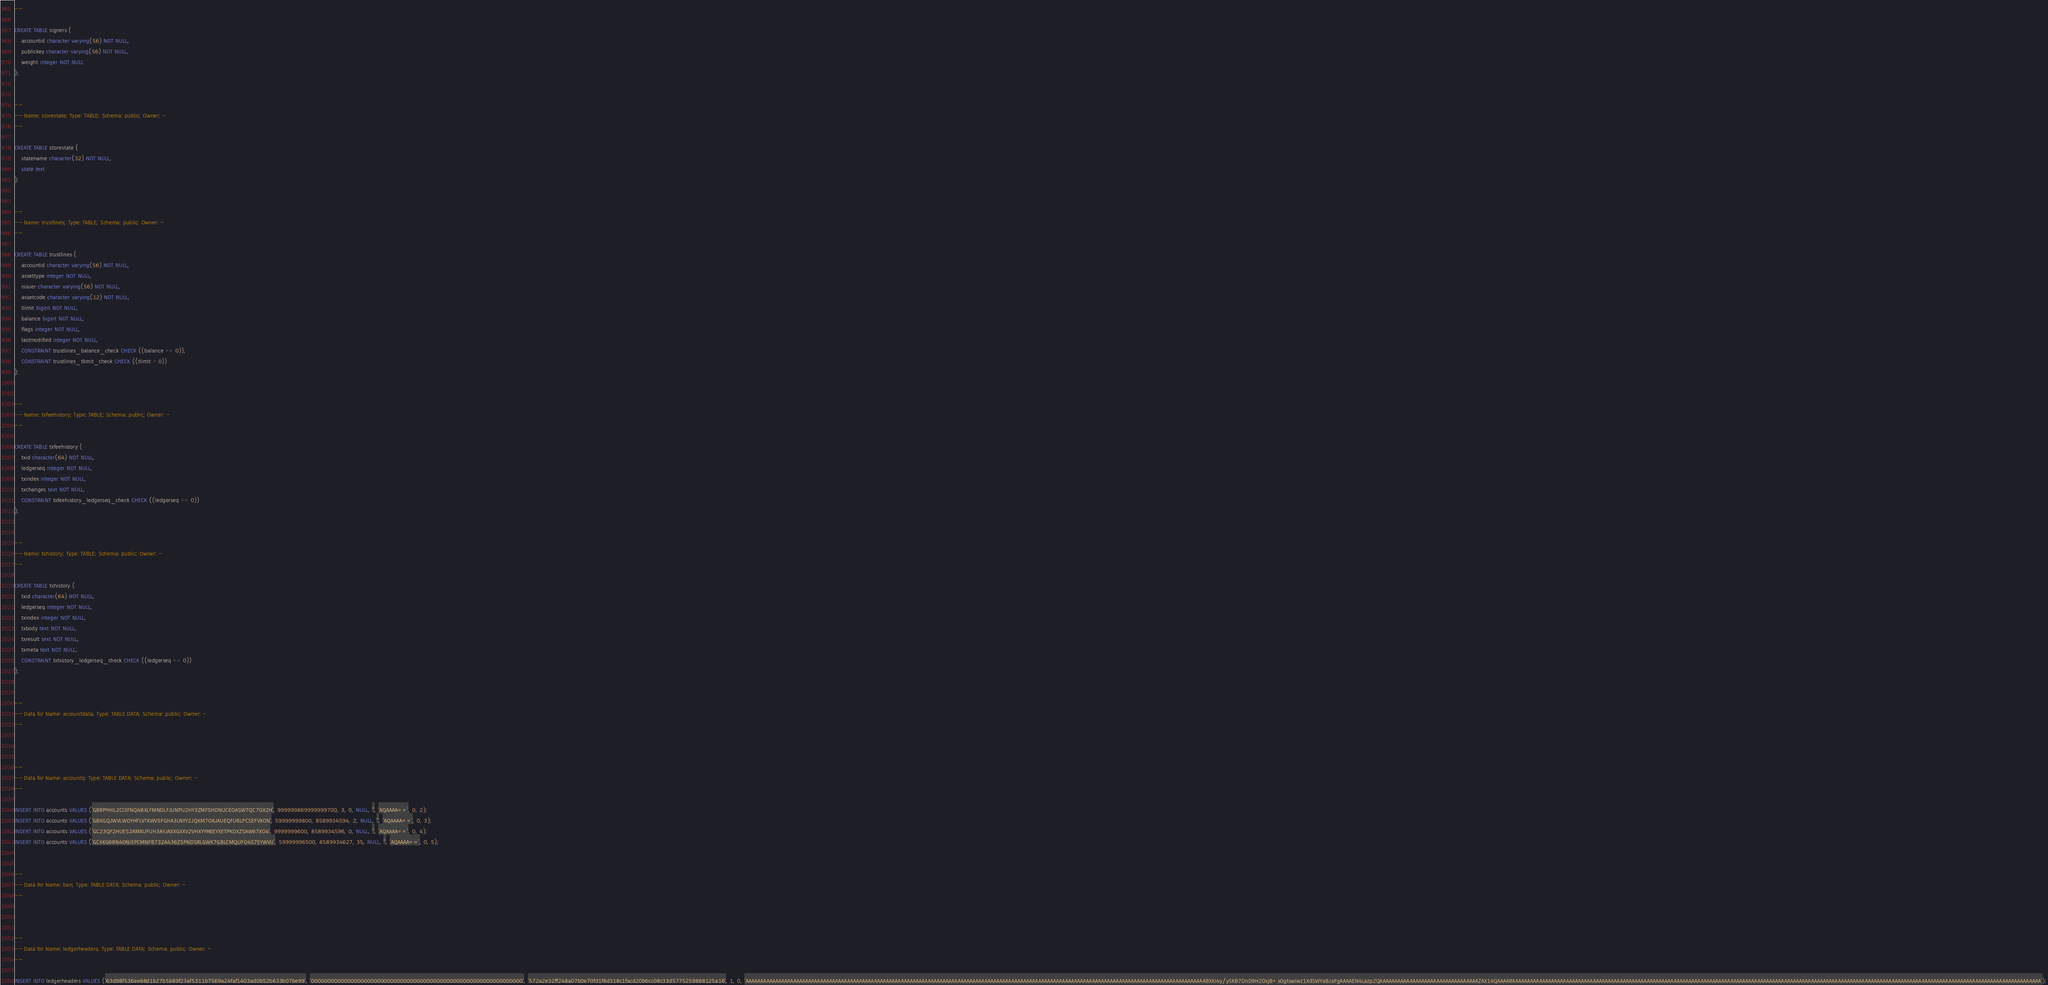<code> <loc_0><loc_0><loc_500><loc_500><_SQL_>--

CREATE TABLE signers (
    accountid character varying(56) NOT NULL,
    publickey character varying(56) NOT NULL,
    weight integer NOT NULL
);


--
-- Name: storestate; Type: TABLE; Schema: public; Owner: -
--

CREATE TABLE storestate (
    statename character(32) NOT NULL,
    state text
);


--
-- Name: trustlines; Type: TABLE; Schema: public; Owner: -
--

CREATE TABLE trustlines (
    accountid character varying(56) NOT NULL,
    assettype integer NOT NULL,
    issuer character varying(56) NOT NULL,
    assetcode character varying(12) NOT NULL,
    tlimit bigint NOT NULL,
    balance bigint NOT NULL,
    flags integer NOT NULL,
    lastmodified integer NOT NULL,
    CONSTRAINT trustlines_balance_check CHECK ((balance >= 0)),
    CONSTRAINT trustlines_tlimit_check CHECK ((tlimit > 0))
);


--
-- Name: txfeehistory; Type: TABLE; Schema: public; Owner: -
--

CREATE TABLE txfeehistory (
    txid character(64) NOT NULL,
    ledgerseq integer NOT NULL,
    txindex integer NOT NULL,
    txchanges text NOT NULL,
    CONSTRAINT txfeehistory_ledgerseq_check CHECK ((ledgerseq >= 0))
);


--
-- Name: txhistory; Type: TABLE; Schema: public; Owner: -
--

CREATE TABLE txhistory (
    txid character(64) NOT NULL,
    ledgerseq integer NOT NULL,
    txindex integer NOT NULL,
    txbody text NOT NULL,
    txresult text NOT NULL,
    txmeta text NOT NULL,
    CONSTRAINT txhistory_ledgerseq_check CHECK ((ledgerseq >= 0))
);


--
-- Data for Name: accountdata; Type: TABLE DATA; Schema: public; Owner: -
--



--
-- Data for Name: accounts; Type: TABLE DATA; Schema: public; Owner: -
--

INSERT INTO accounts VALUES ('GBRPYHIL2CI3FNQ4BXLFMNDLFJUNPU2HY3ZMFSHONUCEOASW7QC7OX2H', 999999869999999700, 3, 0, NULL, '', 'AQAAAA==', 0, 2);
INSERT INTO accounts VALUES ('GBXGQJWVLWOYHFLVTKWV5FGHA3LNYY2JQKM7OAJAUEQFU6LPCSEFVXON', 59999999800, 8589934594, 2, NULL, '', 'AQAAAA==', 0, 3);
INSERT INTO accounts VALUES ('GC23QF2HUE52AMXUFUH3AYJAXXGXXV2VHXYYR6EYXETPKDXZSAW67XO4', 9999999600, 8589934596, 0, NULL, '', 'AQAAAA==', 0, 4);
INSERT INTO accounts VALUES ('GCXKG6RN4ONIEPCMNFB732A436Z5PNDSRLGWK7GBLCMQLIFO4S7EYWVU', 59999996500, 8589934627, 35, NULL, '', 'AQAAAA==', 0, 5);


--
-- Data for Name: ban; Type: TABLE DATA; Schema: public; Owner: -
--



--
-- Data for Name: ledgerheaders; Type: TABLE DATA; Schema: public; Owner: -
--

INSERT INTO ledgerheaders VALUES ('63d98f536ee68d1b27b5b89f23af5311b7569a24faf1403ad0b52b633b07be99', '0000000000000000000000000000000000000000000000000000000000000000', '572a2e32ff248a07b0e70fd1f6d318c1facd20b6cc08c33d5775259868125a16', 1, 0, 'AAAAAAAAAAAAAAAAAAAAAAAAAAAAAAAAAAAAAAAAAAAAAAAAAAAAAAAAAAAAAAAAAAAAAAAAAAAAAAAAAAAAAAAAAAAAAAAAAAAAAAAAAAAAAAAAAAAAAAAAAAAAAAAAAAAAAAAAAAAAAAAAAAAAAAAAAABXKi4y/ySKB7DnD9H20xjB+s0gtswIwz1XdSWYaBJaFgAAAAEN4Lazp2QAAAAAAAAAAAAAAAAAAAAAAAAAAAAAAAAAZAX14QAAAABkAAAAAAAAAAAAAAAAAAAAAAAAAAAAAAAAAAAAAAAAAAAAAAAAAAAAAAAAAAAAAAAAAAAAAAAAAAAAAAAAAAAAAAAAAAAAAAAAAAAAAAAAAAAAAAAAAAAAAAAAAAAAAAAAAAAAAAAAAAAAAAAAAAAAAAAAAAAAAAAAAAAAAAAAAAAAAAAA');</code> 